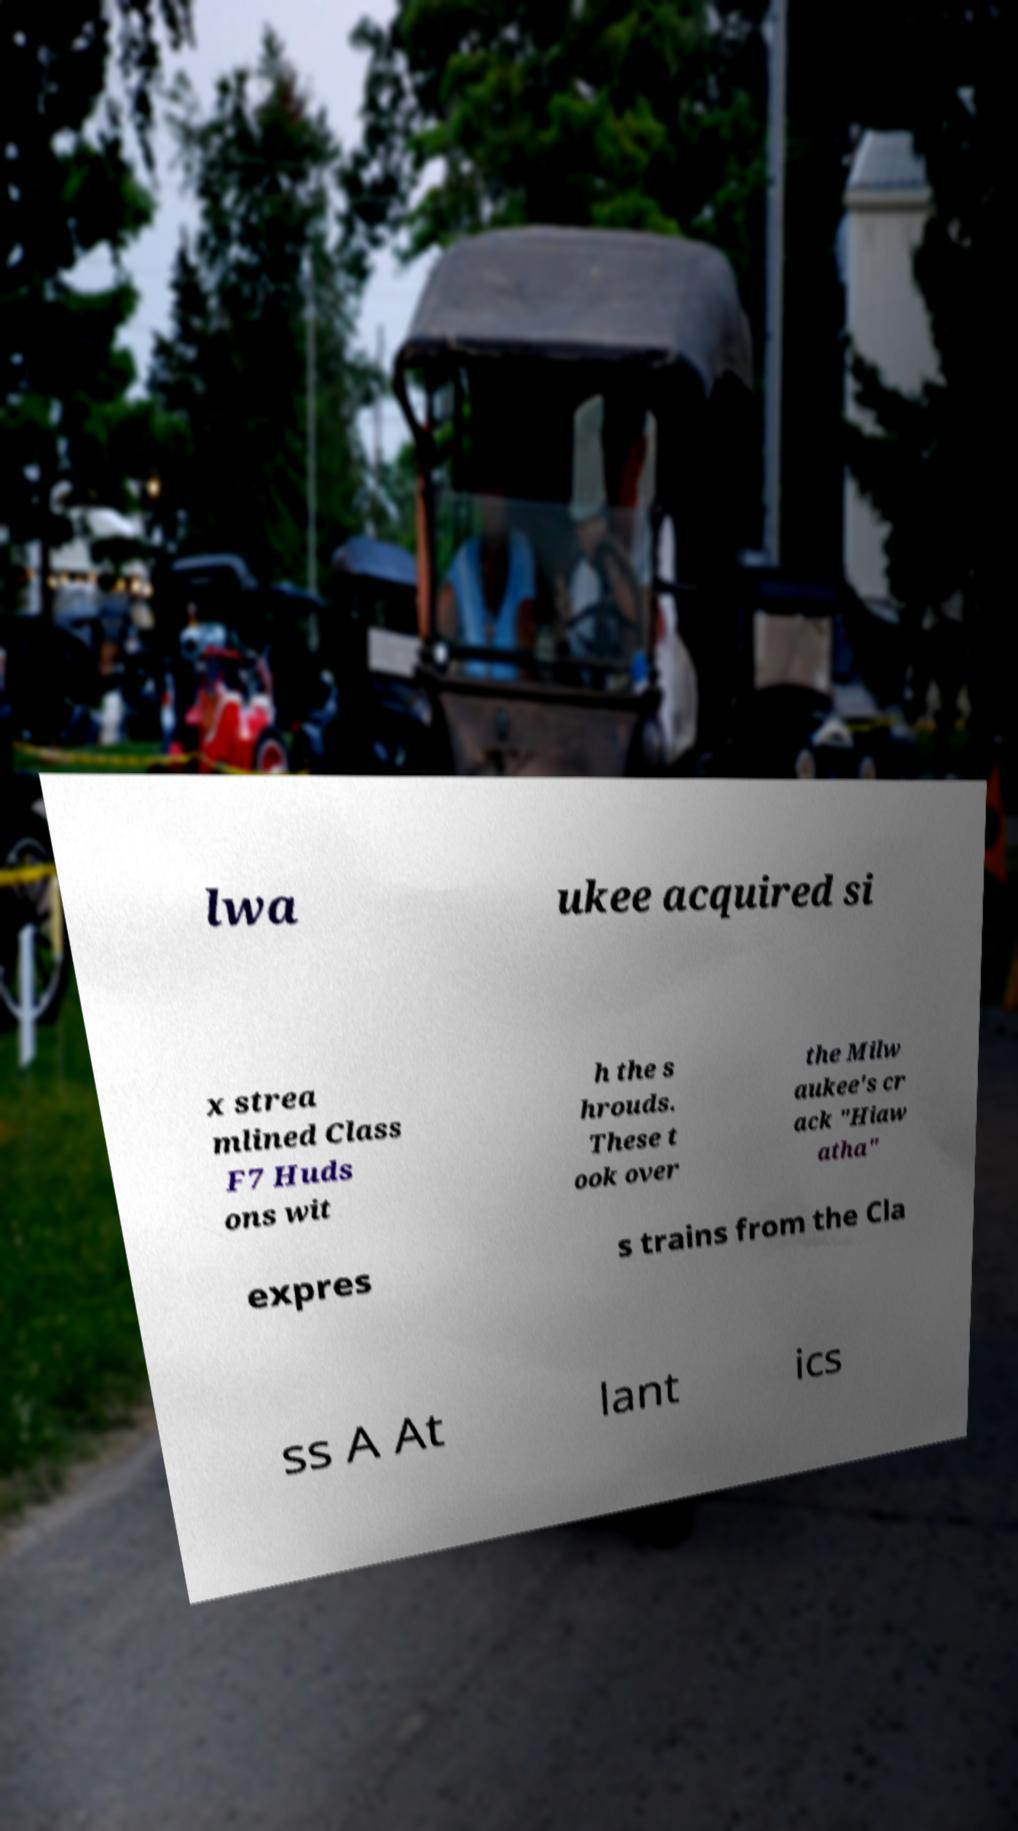What messages or text are displayed in this image? I need them in a readable, typed format. lwa ukee acquired si x strea mlined Class F7 Huds ons wit h the s hrouds. These t ook over the Milw aukee's cr ack "Hiaw atha" expres s trains from the Cla ss A At lant ics 